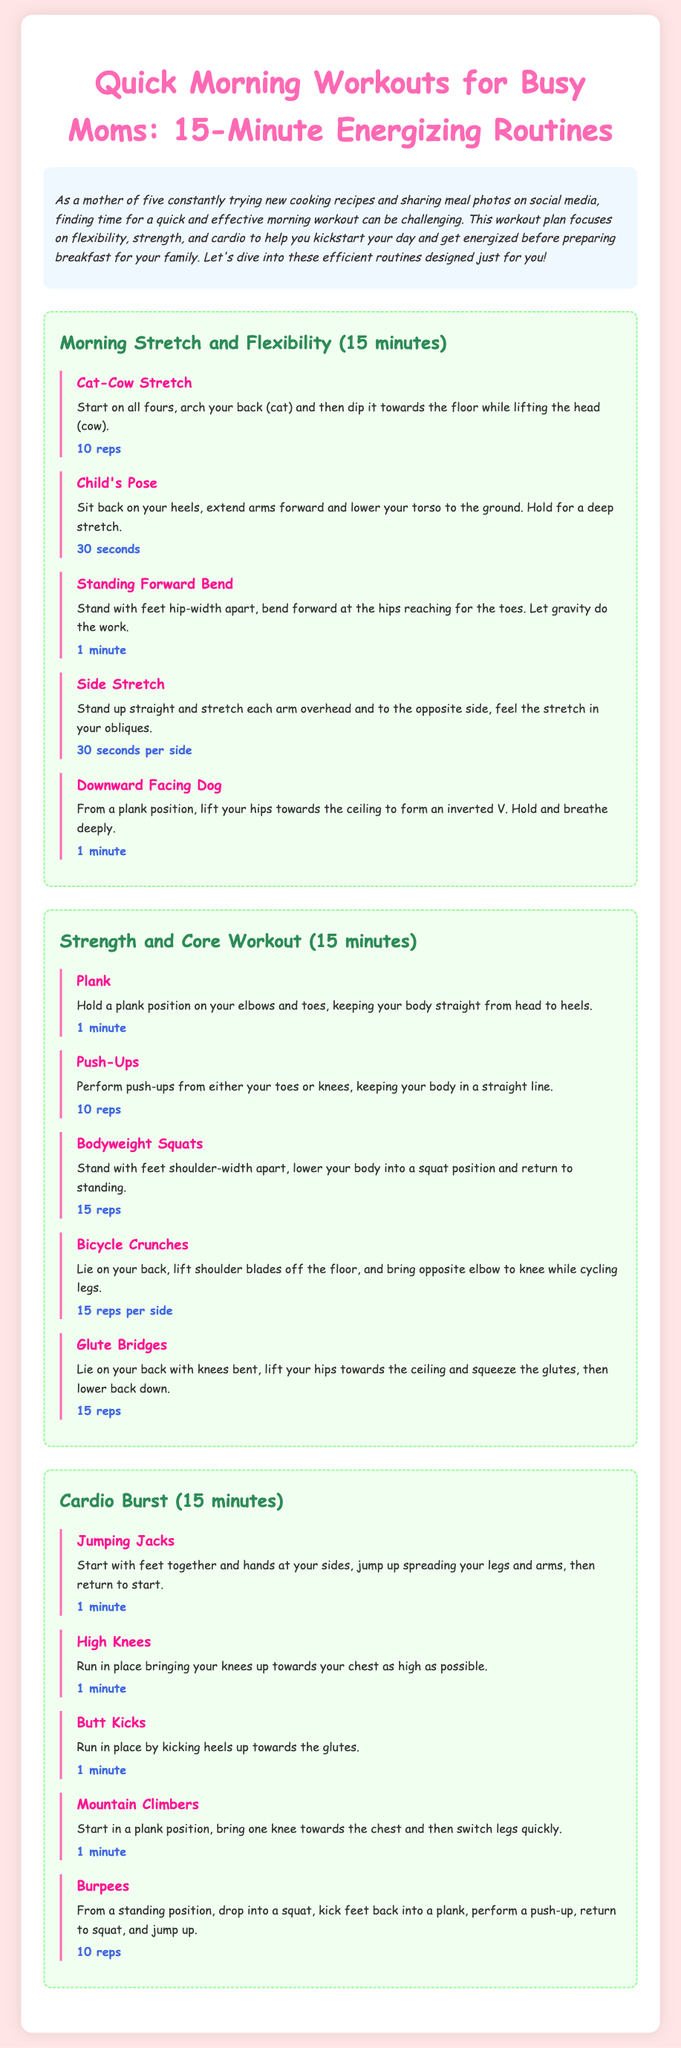what is the total duration of each workout routine? Each workout routine is designed to last for 15 minutes, as stated at the beginning of each section.
Answer: 15 minutes how many children does the author have? The introduction mentions that the author is a mother of five.
Answer: five what is the first exercise in the Morning Stretch and Flexibility routine? The first exercise listed under the Morning Stretch and Flexibility routine is the Cat-Cow Stretch.
Answer: Cat-Cow Stretch how many reps are suggested for Push-Ups? The document specifies that 10 reps are suggested for Push-Ups in the Strength and Core Workout section.
Answer: 10 reps what type of workout is the last routine focused on? The last routine is a Cardio Burst focused on cardiovascular exercises.
Answer: Cardio Burst which exercise requires the subject to hold a position for 1 minute? The Plank exercise requires holding a position for 1 minute, as indicated in the Strength and Core Workout section.
Answer: Plank how many seconds should the Child's Pose be held? The Child's Pose should be held for 30 seconds, according to the instructions.
Answer: 30 seconds name one exercise included in the Strength and Core Workout. One exercise included in the Strength and Core Workout is Bicycle Crunches.
Answer: Bicycle Crunches what is the color of the headings in the routines? The headings in the routines are colored in a shade of teal.
Answer: teal 